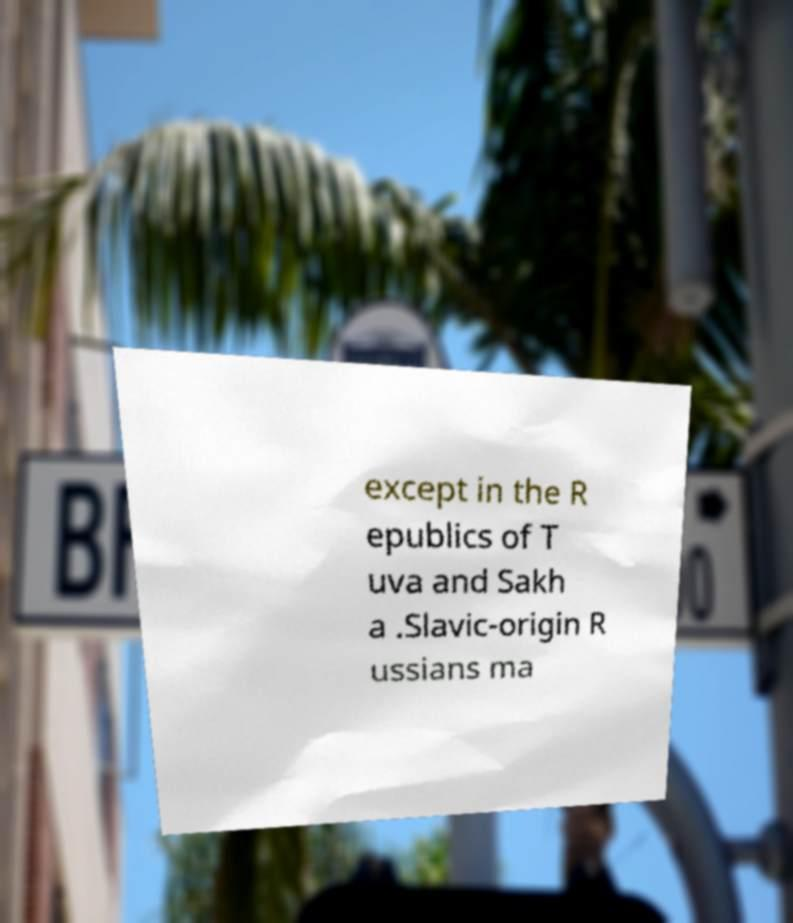I need the written content from this picture converted into text. Can you do that? except in the R epublics of T uva and Sakh a .Slavic-origin R ussians ma 